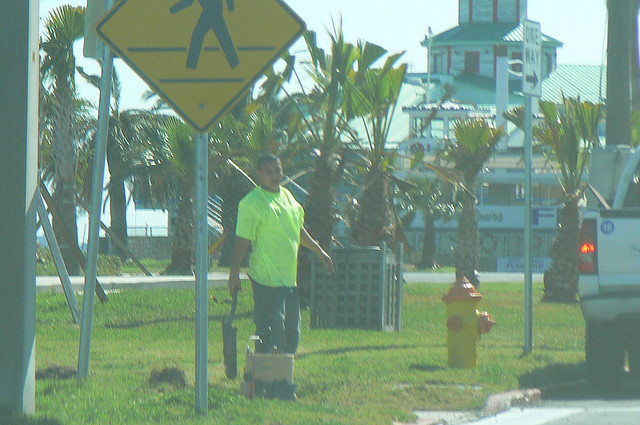Please transcribe the text in this image. ONE WAY 19 